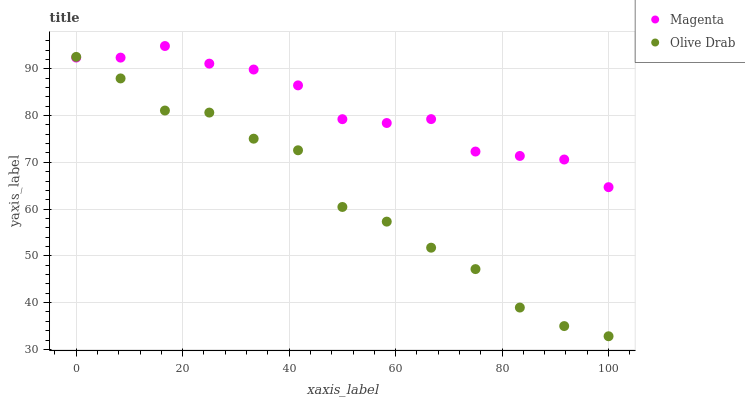Does Olive Drab have the minimum area under the curve?
Answer yes or no. Yes. Does Magenta have the maximum area under the curve?
Answer yes or no. Yes. Does Olive Drab have the maximum area under the curve?
Answer yes or no. No. Is Magenta the smoothest?
Answer yes or no. Yes. Is Olive Drab the roughest?
Answer yes or no. Yes. Is Olive Drab the smoothest?
Answer yes or no. No. Does Olive Drab have the lowest value?
Answer yes or no. Yes. Does Magenta have the highest value?
Answer yes or no. Yes. Does Olive Drab have the highest value?
Answer yes or no. No. Does Magenta intersect Olive Drab?
Answer yes or no. Yes. Is Magenta less than Olive Drab?
Answer yes or no. No. Is Magenta greater than Olive Drab?
Answer yes or no. No. 